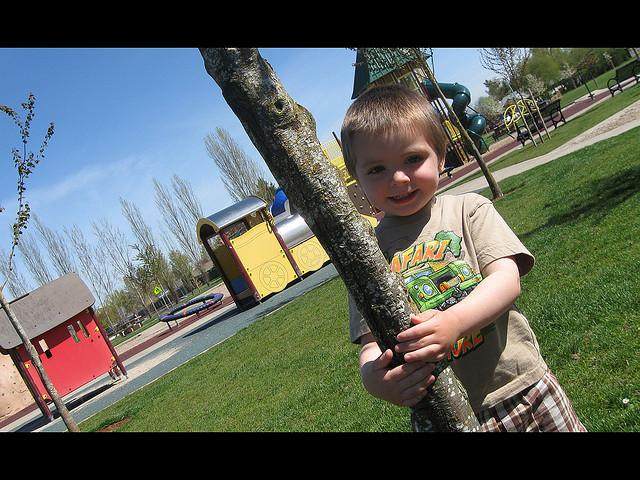At which location does the child hold the tree? Please explain your reasoning. playground. The location is the playground. 